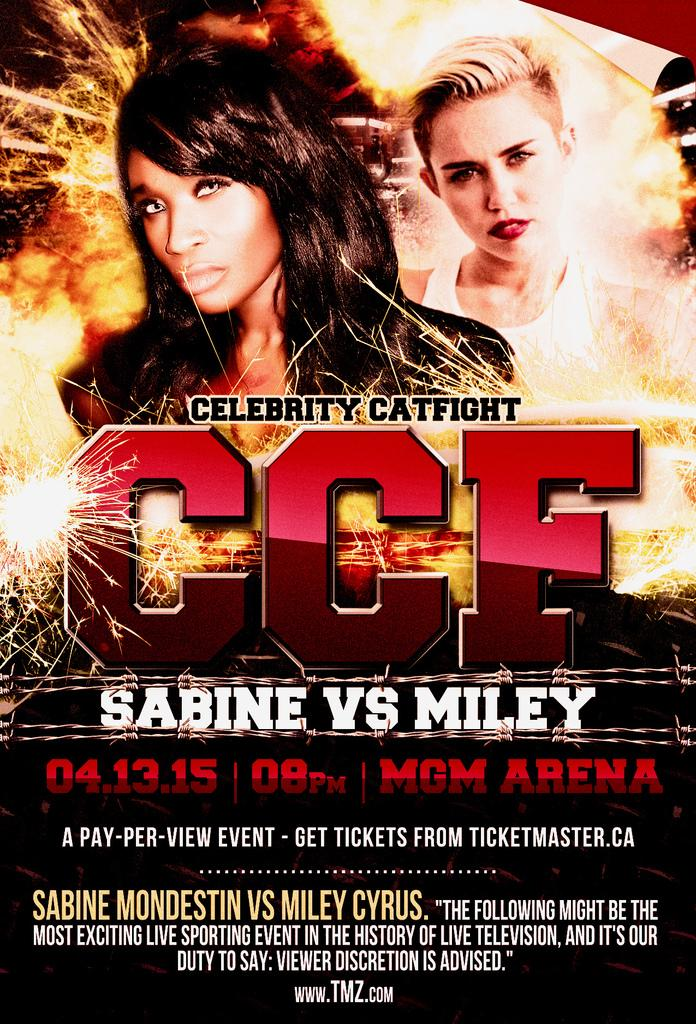<image>
Provide a brief description of the given image. A poster for Celebrity Cat Fight with Miley. 